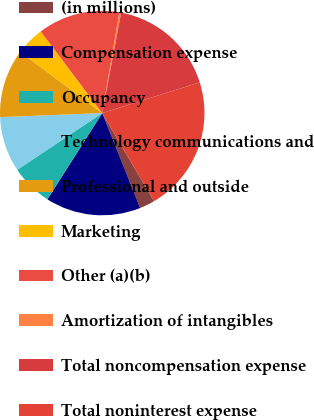Convert chart. <chart><loc_0><loc_0><loc_500><loc_500><pie_chart><fcel>(in millions)<fcel>Compensation expense<fcel>Occupancy<fcel>Technology communications and<fcel>Professional and outside<fcel>Marketing<fcel>Other (a)(b)<fcel>Amortization of intangibles<fcel>Total noncompensation expense<fcel>Total noninterest expense<nl><fcel>2.4%<fcel>15.07%<fcel>6.62%<fcel>8.73%<fcel>10.84%<fcel>4.51%<fcel>12.96%<fcel>0.29%<fcel>17.18%<fcel>21.4%<nl></chart> 